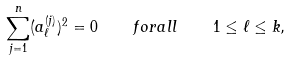Convert formula to latex. <formula><loc_0><loc_0><loc_500><loc_500>\sum _ { j = 1 } ^ { n } ( a _ { \ell } ^ { ( j ) } ) ^ { 2 } = 0 \quad f o r a l l \quad 1 \leq \ell \leq k ,</formula> 